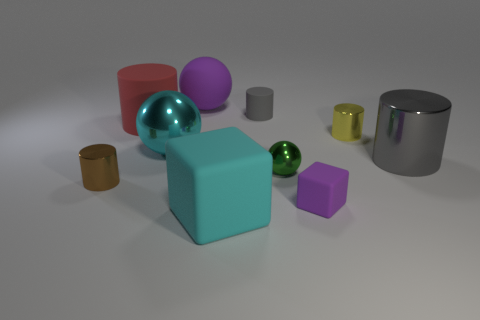Subtract all gray metal cylinders. How many cylinders are left? 4 Subtract 1 cylinders. How many cylinders are left? 4 Subtract all yellow cylinders. How many cylinders are left? 4 Subtract all cyan cylinders. Subtract all gray cubes. How many cylinders are left? 5 Subtract all spheres. How many objects are left? 7 Subtract all big shiny cylinders. Subtract all tiny blue metallic blocks. How many objects are left? 9 Add 5 tiny green objects. How many tiny green objects are left? 6 Add 8 matte spheres. How many matte spheres exist? 9 Subtract 0 brown spheres. How many objects are left? 10 